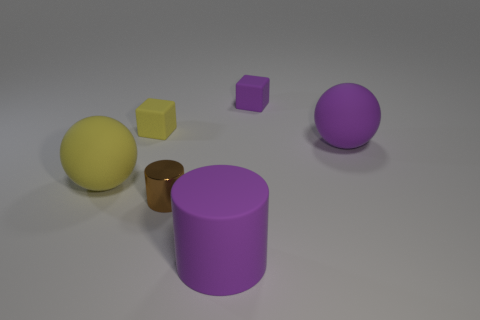Add 1 big yellow spheres. How many objects exist? 7 Subtract all cylinders. How many objects are left? 4 Subtract 0 red blocks. How many objects are left? 6 Subtract all rubber cylinders. Subtract all yellow balls. How many objects are left? 4 Add 2 tiny metal things. How many tiny metal things are left? 3 Add 1 big yellow metallic balls. How many big yellow metallic balls exist? 1 